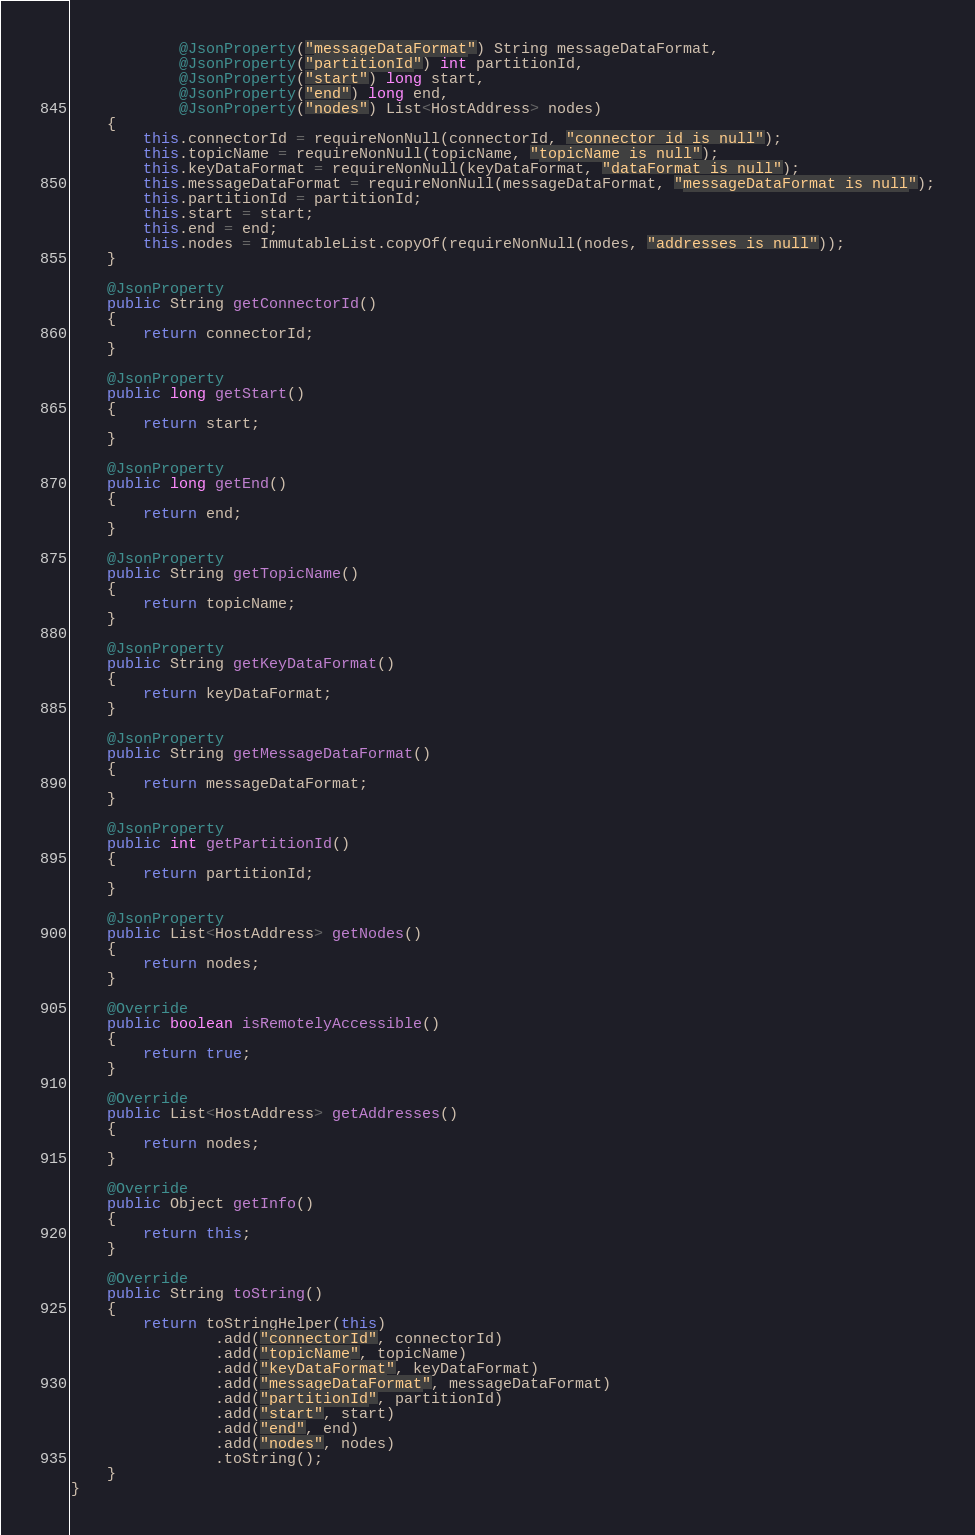<code> <loc_0><loc_0><loc_500><loc_500><_Java_>            @JsonProperty("messageDataFormat") String messageDataFormat,
            @JsonProperty("partitionId") int partitionId,
            @JsonProperty("start") long start,
            @JsonProperty("end") long end,
            @JsonProperty("nodes") List<HostAddress> nodes)
    {
        this.connectorId = requireNonNull(connectorId, "connector id is null");
        this.topicName = requireNonNull(topicName, "topicName is null");
        this.keyDataFormat = requireNonNull(keyDataFormat, "dataFormat is null");
        this.messageDataFormat = requireNonNull(messageDataFormat, "messageDataFormat is null");
        this.partitionId = partitionId;
        this.start = start;
        this.end = end;
        this.nodes = ImmutableList.copyOf(requireNonNull(nodes, "addresses is null"));
    }

    @JsonProperty
    public String getConnectorId()
    {
        return connectorId;
    }

    @JsonProperty
    public long getStart()
    {
        return start;
    }

    @JsonProperty
    public long getEnd()
    {
        return end;
    }

    @JsonProperty
    public String getTopicName()
    {
        return topicName;
    }

    @JsonProperty
    public String getKeyDataFormat()
    {
        return keyDataFormat;
    }

    @JsonProperty
    public String getMessageDataFormat()
    {
        return messageDataFormat;
    }

    @JsonProperty
    public int getPartitionId()
    {
        return partitionId;
    }

    @JsonProperty
    public List<HostAddress> getNodes()
    {
        return nodes;
    }

    @Override
    public boolean isRemotelyAccessible()
    {
        return true;
    }

    @Override
    public List<HostAddress> getAddresses()
    {
        return nodes;
    }

    @Override
    public Object getInfo()
    {
        return this;
    }

    @Override
    public String toString()
    {
        return toStringHelper(this)
                .add("connectorId", connectorId)
                .add("topicName", topicName)
                .add("keyDataFormat", keyDataFormat)
                .add("messageDataFormat", messageDataFormat)
                .add("partitionId", partitionId)
                .add("start", start)
                .add("end", end)
                .add("nodes", nodes)
                .toString();
    }
}
</code> 